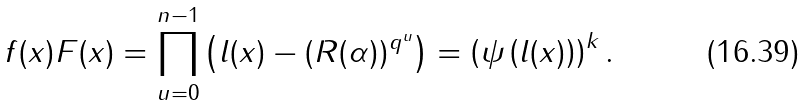<formula> <loc_0><loc_0><loc_500><loc_500>f ( x ) F ( x ) = \prod _ { u = 0 } ^ { n - 1 } \left ( l ( x ) - ( R ( \alpha ) ) ^ { q ^ { u } } \right ) = \left ( \psi \left ( l ( x ) \right ) \right ) ^ { k } .</formula> 